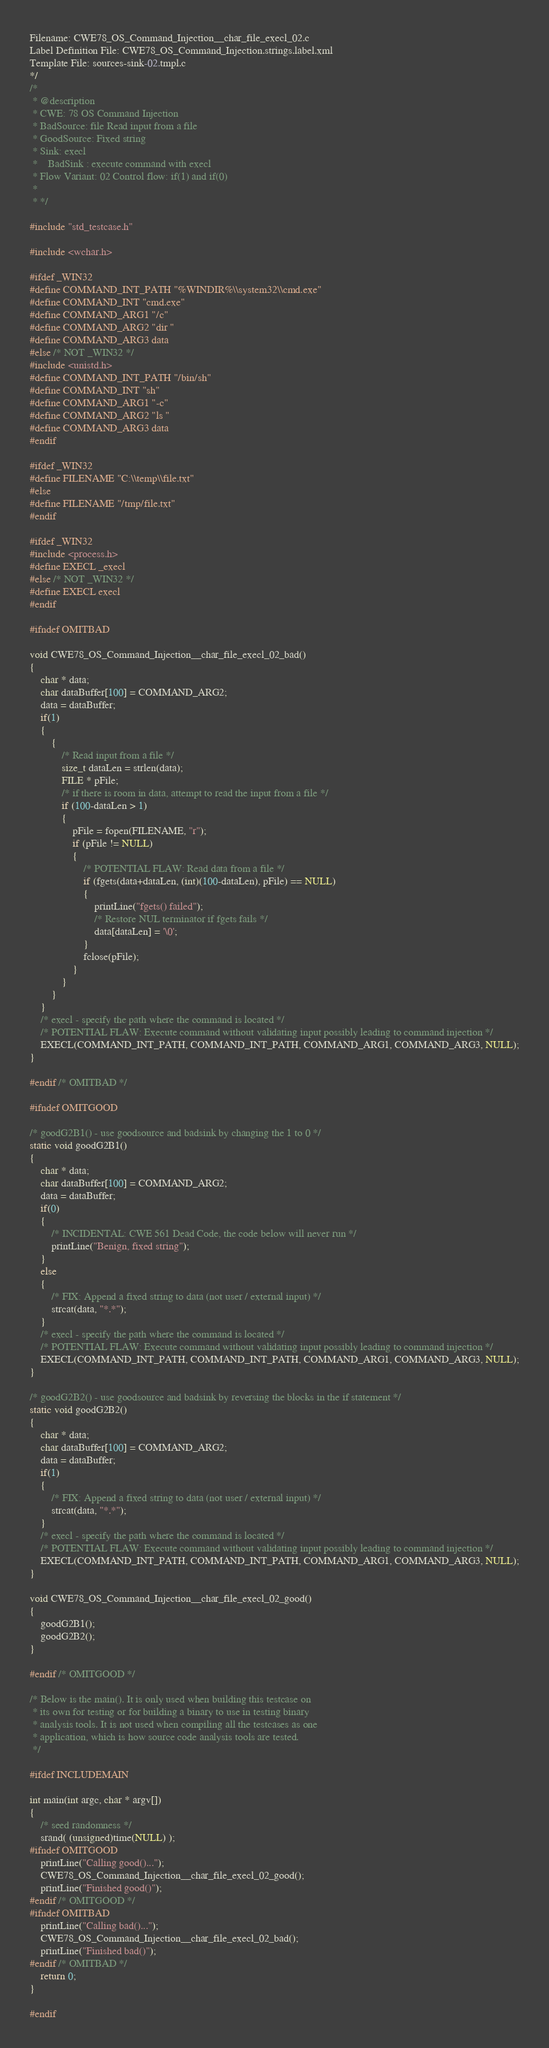Convert code to text. <code><loc_0><loc_0><loc_500><loc_500><_C_>Filename: CWE78_OS_Command_Injection__char_file_execl_02.c
Label Definition File: CWE78_OS_Command_Injection.strings.label.xml
Template File: sources-sink-02.tmpl.c
*/
/*
 * @description
 * CWE: 78 OS Command Injection
 * BadSource: file Read input from a file
 * GoodSource: Fixed string
 * Sink: execl
 *    BadSink : execute command with execl
 * Flow Variant: 02 Control flow: if(1) and if(0)
 *
 * */

#include "std_testcase.h"

#include <wchar.h>

#ifdef _WIN32
#define COMMAND_INT_PATH "%WINDIR%\\system32\\cmd.exe"
#define COMMAND_INT "cmd.exe"
#define COMMAND_ARG1 "/c"
#define COMMAND_ARG2 "dir "
#define COMMAND_ARG3 data
#else /* NOT _WIN32 */
#include <unistd.h>
#define COMMAND_INT_PATH "/bin/sh"
#define COMMAND_INT "sh"
#define COMMAND_ARG1 "-c"
#define COMMAND_ARG2 "ls "
#define COMMAND_ARG3 data
#endif

#ifdef _WIN32
#define FILENAME "C:\\temp\\file.txt"
#else
#define FILENAME "/tmp/file.txt"
#endif

#ifdef _WIN32
#include <process.h>
#define EXECL _execl
#else /* NOT _WIN32 */
#define EXECL execl
#endif

#ifndef OMITBAD

void CWE78_OS_Command_Injection__char_file_execl_02_bad()
{
    char * data;
    char dataBuffer[100] = COMMAND_ARG2;
    data = dataBuffer;
    if(1)
    {
        {
            /* Read input from a file */
            size_t dataLen = strlen(data);
            FILE * pFile;
            /* if there is room in data, attempt to read the input from a file */
            if (100-dataLen > 1)
            {
                pFile = fopen(FILENAME, "r");
                if (pFile != NULL)
                {
                    /* POTENTIAL FLAW: Read data from a file */
                    if (fgets(data+dataLen, (int)(100-dataLen), pFile) == NULL)
                    {
                        printLine("fgets() failed");
                        /* Restore NUL terminator if fgets fails */
                        data[dataLen] = '\0';
                    }
                    fclose(pFile);
                }
            }
        }
    }
    /* execl - specify the path where the command is located */
    /* POTENTIAL FLAW: Execute command without validating input possibly leading to command injection */
    EXECL(COMMAND_INT_PATH, COMMAND_INT_PATH, COMMAND_ARG1, COMMAND_ARG3, NULL);
}

#endif /* OMITBAD */

#ifndef OMITGOOD

/* goodG2B1() - use goodsource and badsink by changing the 1 to 0 */
static void goodG2B1()
{
    char * data;
    char dataBuffer[100] = COMMAND_ARG2;
    data = dataBuffer;
    if(0)
    {
        /* INCIDENTAL: CWE 561 Dead Code, the code below will never run */
        printLine("Benign, fixed string");
    }
    else
    {
        /* FIX: Append a fixed string to data (not user / external input) */
        strcat(data, "*.*");
    }
    /* execl - specify the path where the command is located */
    /* POTENTIAL FLAW: Execute command without validating input possibly leading to command injection */
    EXECL(COMMAND_INT_PATH, COMMAND_INT_PATH, COMMAND_ARG1, COMMAND_ARG3, NULL);
}

/* goodG2B2() - use goodsource and badsink by reversing the blocks in the if statement */
static void goodG2B2()
{
    char * data;
    char dataBuffer[100] = COMMAND_ARG2;
    data = dataBuffer;
    if(1)
    {
        /* FIX: Append a fixed string to data (not user / external input) */
        strcat(data, "*.*");
    }
    /* execl - specify the path where the command is located */
    /* POTENTIAL FLAW: Execute command without validating input possibly leading to command injection */
    EXECL(COMMAND_INT_PATH, COMMAND_INT_PATH, COMMAND_ARG1, COMMAND_ARG3, NULL);
}

void CWE78_OS_Command_Injection__char_file_execl_02_good()
{
    goodG2B1();
    goodG2B2();
}

#endif /* OMITGOOD */

/* Below is the main(). It is only used when building this testcase on
 * its own for testing or for building a binary to use in testing binary
 * analysis tools. It is not used when compiling all the testcases as one
 * application, which is how source code analysis tools are tested.
 */

#ifdef INCLUDEMAIN

int main(int argc, char * argv[])
{
    /* seed randomness */
    srand( (unsigned)time(NULL) );
#ifndef OMITGOOD
    printLine("Calling good()...");
    CWE78_OS_Command_Injection__char_file_execl_02_good();
    printLine("Finished good()");
#endif /* OMITGOOD */
#ifndef OMITBAD
    printLine("Calling bad()...");
    CWE78_OS_Command_Injection__char_file_execl_02_bad();
    printLine("Finished bad()");
#endif /* OMITBAD */
    return 0;
}

#endif
</code> 